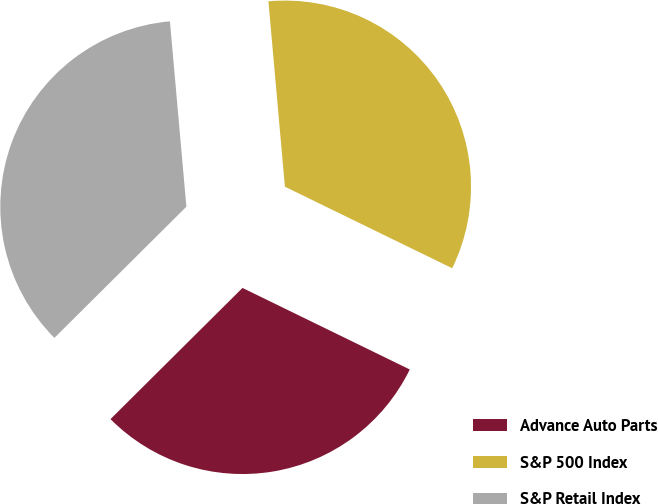Convert chart to OTSL. <chart><loc_0><loc_0><loc_500><loc_500><pie_chart><fcel>Advance Auto Parts<fcel>S&P 500 Index<fcel>S&P Retail Index<nl><fcel>30.33%<fcel>33.63%<fcel>36.04%<nl></chart> 